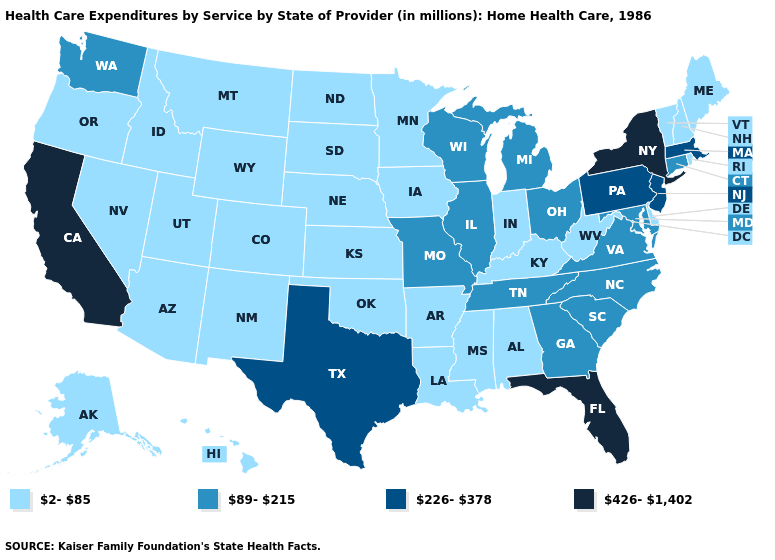What is the value of Minnesota?
Short answer required. 2-85. Which states hav the highest value in the MidWest?
Quick response, please. Illinois, Michigan, Missouri, Ohio, Wisconsin. What is the value of New Hampshire?
Be succinct. 2-85. Does California have the highest value in the West?
Write a very short answer. Yes. What is the value of Nevada?
Answer briefly. 2-85. Name the states that have a value in the range 426-1,402?
Quick response, please. California, Florida, New York. What is the highest value in the USA?
Answer briefly. 426-1,402. Does Utah have the lowest value in the West?
Be succinct. Yes. What is the value of Alabama?
Be succinct. 2-85. What is the value of South Carolina?
Quick response, please. 89-215. What is the lowest value in states that border New Hampshire?
Answer briefly. 2-85. Name the states that have a value in the range 226-378?
Quick response, please. Massachusetts, New Jersey, Pennsylvania, Texas. Name the states that have a value in the range 426-1,402?
Answer briefly. California, Florida, New York. Which states hav the highest value in the Northeast?
Give a very brief answer. New York. 